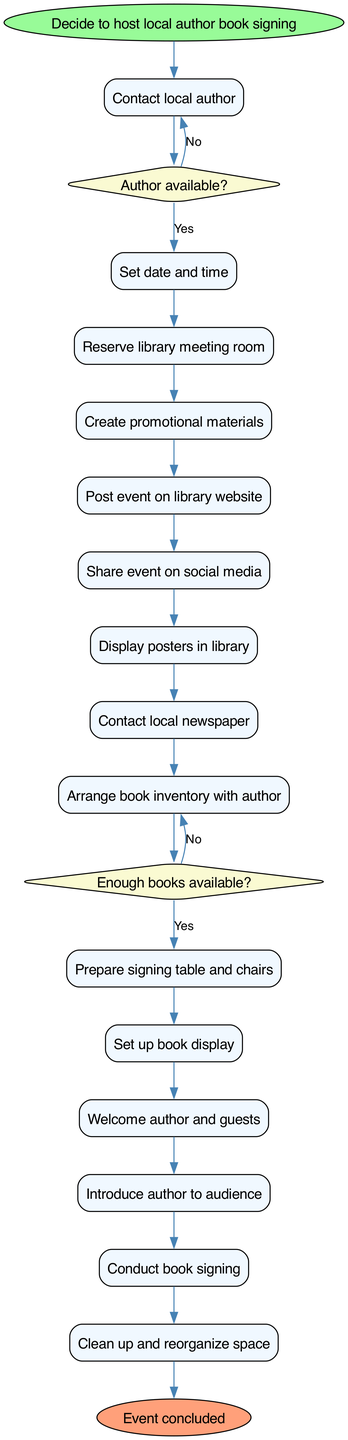What is the start node of the diagram? The start node is clearly indicated and labeled as "Decide to host local author book signing." This is the first step that begins the diagram.
Answer: Decide to host local author book signing What is the end node of the diagram? The end node is labeled as "Event concluded." This marks the final step in the activity diagram, where the process comes to a close after all activities have been completed.
Answer: Event concluded How many decision nodes are present in the diagram? There are two decision nodes in the diagram, corresponding to questions about the author's availability and the inventory of books. Each decision node leads to different paths depending on the answers.
Answer: 2 What activity follows the decision about the author's availability if the answer is yes? If the answer to the author’s availability is yes, the next activity indicated in the diagram is "Set date and time." This shows that the planning continues from there.
Answer: Set date and time What happens if there are not enough books available? If there are not enough books available, the flow indicates that the next action is to "Order more books." This means that the process addresses the inventory issue before proceeding.
Answer: Order more books Which activities are connected directly after creating promotional materials? After "Create promotional materials," the diagram shows three direct activities connected in sequence: "Post event on library website," "Share event on social media," and "Display posters in library." This signifies the promotional phase directly following material creation.
Answer: Post event on library website, Share event on social media, Display posters in library What is the total number of activities involved in organizing the event? The diagram lists a total of 14 activities that are performed as part of the event organization process. This includes everything from contacting the author to cleaning up after the event.
Answer: 14 What is the sequence of steps following the author's welcome to the guests? During the event, after welcoming the author and guests, the next steps in sequence are "Introduce author to audience" followed by "Conduct book signing." So, these activities follow the initial welcome.
Answer: Introduce author to audience, Conduct book signing What type of diagram is displayed here? The diagram is an activity diagram, which is used to show the flow of activities and decisions involved in running a specific process, such as organizing a book signing event.
Answer: Activity diagram 